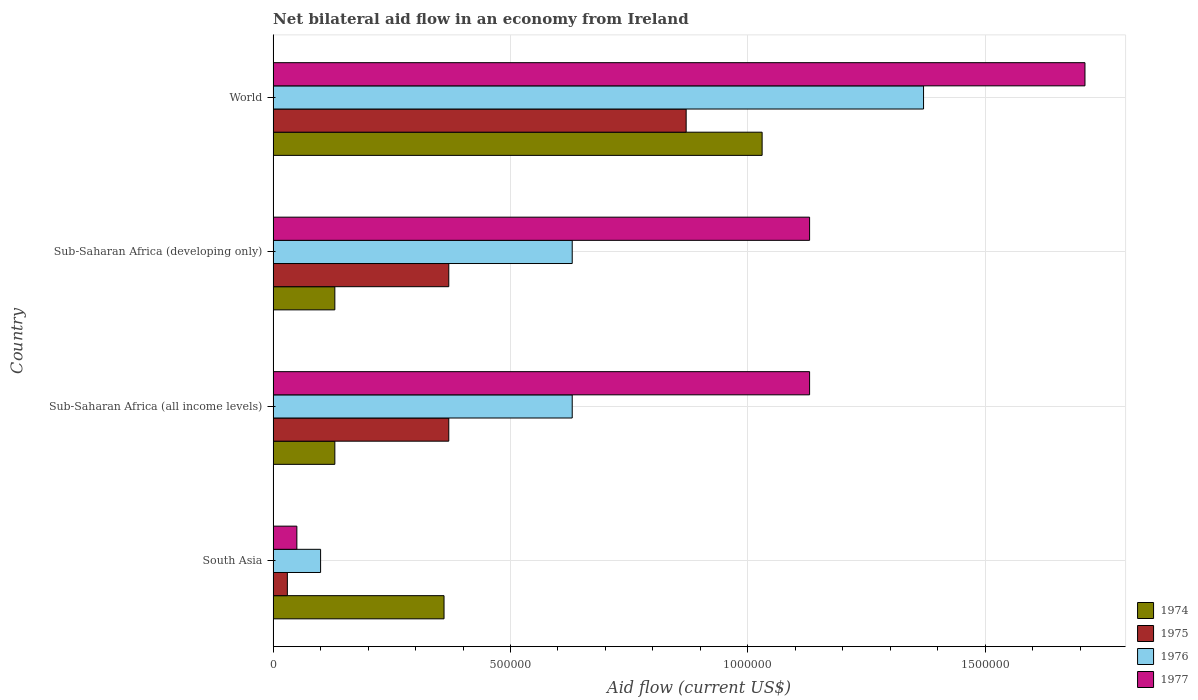How many bars are there on the 2nd tick from the top?
Offer a terse response. 4. What is the label of the 3rd group of bars from the top?
Provide a succinct answer. Sub-Saharan Africa (all income levels). Across all countries, what is the maximum net bilateral aid flow in 1975?
Your answer should be compact. 8.70e+05. Across all countries, what is the minimum net bilateral aid flow in 1977?
Your answer should be very brief. 5.00e+04. In which country was the net bilateral aid flow in 1977 maximum?
Give a very brief answer. World. What is the total net bilateral aid flow in 1974 in the graph?
Offer a terse response. 1.65e+06. What is the difference between the net bilateral aid flow in 1974 in South Asia and that in Sub-Saharan Africa (developing only)?
Ensure brevity in your answer.  2.30e+05. What is the difference between the net bilateral aid flow in 1974 in South Asia and the net bilateral aid flow in 1975 in Sub-Saharan Africa (all income levels)?
Ensure brevity in your answer.  -10000. What is the average net bilateral aid flow in 1977 per country?
Offer a very short reply. 1.00e+06. What is the difference between the net bilateral aid flow in 1974 and net bilateral aid flow in 1977 in World?
Offer a terse response. -6.80e+05. What is the ratio of the net bilateral aid flow in 1975 in Sub-Saharan Africa (developing only) to that in World?
Your answer should be compact. 0.43. Is the net bilateral aid flow in 1976 in South Asia less than that in Sub-Saharan Africa (developing only)?
Offer a very short reply. Yes. What is the difference between the highest and the second highest net bilateral aid flow in 1974?
Give a very brief answer. 6.70e+05. What is the difference between the highest and the lowest net bilateral aid flow in 1976?
Keep it short and to the point. 1.27e+06. Is the sum of the net bilateral aid flow in 1977 in Sub-Saharan Africa (developing only) and World greater than the maximum net bilateral aid flow in 1975 across all countries?
Ensure brevity in your answer.  Yes. Is it the case that in every country, the sum of the net bilateral aid flow in 1975 and net bilateral aid flow in 1974 is greater than the sum of net bilateral aid flow in 1977 and net bilateral aid flow in 1976?
Offer a very short reply. No. What does the 2nd bar from the top in South Asia represents?
Provide a succinct answer. 1976. Are all the bars in the graph horizontal?
Your answer should be very brief. Yes. Does the graph contain any zero values?
Your answer should be very brief. No. Does the graph contain grids?
Keep it short and to the point. Yes. Where does the legend appear in the graph?
Give a very brief answer. Bottom right. How many legend labels are there?
Ensure brevity in your answer.  4. How are the legend labels stacked?
Your answer should be compact. Vertical. What is the title of the graph?
Ensure brevity in your answer.  Net bilateral aid flow in an economy from Ireland. What is the label or title of the X-axis?
Offer a very short reply. Aid flow (current US$). What is the label or title of the Y-axis?
Offer a very short reply. Country. What is the Aid flow (current US$) in 1975 in Sub-Saharan Africa (all income levels)?
Make the answer very short. 3.70e+05. What is the Aid flow (current US$) in 1976 in Sub-Saharan Africa (all income levels)?
Make the answer very short. 6.30e+05. What is the Aid flow (current US$) in 1977 in Sub-Saharan Africa (all income levels)?
Provide a succinct answer. 1.13e+06. What is the Aid flow (current US$) of 1975 in Sub-Saharan Africa (developing only)?
Keep it short and to the point. 3.70e+05. What is the Aid flow (current US$) in 1976 in Sub-Saharan Africa (developing only)?
Your answer should be compact. 6.30e+05. What is the Aid flow (current US$) of 1977 in Sub-Saharan Africa (developing only)?
Ensure brevity in your answer.  1.13e+06. What is the Aid flow (current US$) of 1974 in World?
Make the answer very short. 1.03e+06. What is the Aid flow (current US$) of 1975 in World?
Offer a terse response. 8.70e+05. What is the Aid flow (current US$) of 1976 in World?
Offer a very short reply. 1.37e+06. What is the Aid flow (current US$) in 1977 in World?
Keep it short and to the point. 1.71e+06. Across all countries, what is the maximum Aid flow (current US$) in 1974?
Make the answer very short. 1.03e+06. Across all countries, what is the maximum Aid flow (current US$) of 1975?
Your response must be concise. 8.70e+05. Across all countries, what is the maximum Aid flow (current US$) of 1976?
Provide a succinct answer. 1.37e+06. Across all countries, what is the maximum Aid flow (current US$) of 1977?
Keep it short and to the point. 1.71e+06. Across all countries, what is the minimum Aid flow (current US$) of 1974?
Offer a very short reply. 1.30e+05. What is the total Aid flow (current US$) in 1974 in the graph?
Offer a very short reply. 1.65e+06. What is the total Aid flow (current US$) of 1975 in the graph?
Offer a very short reply. 1.64e+06. What is the total Aid flow (current US$) in 1976 in the graph?
Make the answer very short. 2.73e+06. What is the total Aid flow (current US$) in 1977 in the graph?
Give a very brief answer. 4.02e+06. What is the difference between the Aid flow (current US$) of 1976 in South Asia and that in Sub-Saharan Africa (all income levels)?
Your answer should be compact. -5.30e+05. What is the difference between the Aid flow (current US$) in 1977 in South Asia and that in Sub-Saharan Africa (all income levels)?
Make the answer very short. -1.08e+06. What is the difference between the Aid flow (current US$) of 1976 in South Asia and that in Sub-Saharan Africa (developing only)?
Your answer should be compact. -5.30e+05. What is the difference between the Aid flow (current US$) of 1977 in South Asia and that in Sub-Saharan Africa (developing only)?
Offer a terse response. -1.08e+06. What is the difference between the Aid flow (current US$) of 1974 in South Asia and that in World?
Your response must be concise. -6.70e+05. What is the difference between the Aid flow (current US$) of 1975 in South Asia and that in World?
Offer a terse response. -8.40e+05. What is the difference between the Aid flow (current US$) in 1976 in South Asia and that in World?
Offer a very short reply. -1.27e+06. What is the difference between the Aid flow (current US$) in 1977 in South Asia and that in World?
Provide a short and direct response. -1.66e+06. What is the difference between the Aid flow (current US$) in 1974 in Sub-Saharan Africa (all income levels) and that in Sub-Saharan Africa (developing only)?
Your answer should be compact. 0. What is the difference between the Aid flow (current US$) of 1975 in Sub-Saharan Africa (all income levels) and that in Sub-Saharan Africa (developing only)?
Your answer should be very brief. 0. What is the difference between the Aid flow (current US$) of 1976 in Sub-Saharan Africa (all income levels) and that in Sub-Saharan Africa (developing only)?
Provide a succinct answer. 0. What is the difference between the Aid flow (current US$) of 1974 in Sub-Saharan Africa (all income levels) and that in World?
Your answer should be very brief. -9.00e+05. What is the difference between the Aid flow (current US$) in 1975 in Sub-Saharan Africa (all income levels) and that in World?
Keep it short and to the point. -5.00e+05. What is the difference between the Aid flow (current US$) in 1976 in Sub-Saharan Africa (all income levels) and that in World?
Your response must be concise. -7.40e+05. What is the difference between the Aid flow (current US$) in 1977 in Sub-Saharan Africa (all income levels) and that in World?
Give a very brief answer. -5.80e+05. What is the difference between the Aid flow (current US$) in 1974 in Sub-Saharan Africa (developing only) and that in World?
Your answer should be compact. -9.00e+05. What is the difference between the Aid flow (current US$) in 1975 in Sub-Saharan Africa (developing only) and that in World?
Make the answer very short. -5.00e+05. What is the difference between the Aid flow (current US$) in 1976 in Sub-Saharan Africa (developing only) and that in World?
Make the answer very short. -7.40e+05. What is the difference between the Aid flow (current US$) in 1977 in Sub-Saharan Africa (developing only) and that in World?
Your response must be concise. -5.80e+05. What is the difference between the Aid flow (current US$) in 1974 in South Asia and the Aid flow (current US$) in 1975 in Sub-Saharan Africa (all income levels)?
Provide a short and direct response. -10000. What is the difference between the Aid flow (current US$) in 1974 in South Asia and the Aid flow (current US$) in 1977 in Sub-Saharan Africa (all income levels)?
Give a very brief answer. -7.70e+05. What is the difference between the Aid flow (current US$) of 1975 in South Asia and the Aid flow (current US$) of 1976 in Sub-Saharan Africa (all income levels)?
Your response must be concise. -6.00e+05. What is the difference between the Aid flow (current US$) in 1975 in South Asia and the Aid flow (current US$) in 1977 in Sub-Saharan Africa (all income levels)?
Give a very brief answer. -1.10e+06. What is the difference between the Aid flow (current US$) of 1976 in South Asia and the Aid flow (current US$) of 1977 in Sub-Saharan Africa (all income levels)?
Provide a succinct answer. -1.03e+06. What is the difference between the Aid flow (current US$) in 1974 in South Asia and the Aid flow (current US$) in 1976 in Sub-Saharan Africa (developing only)?
Provide a short and direct response. -2.70e+05. What is the difference between the Aid flow (current US$) of 1974 in South Asia and the Aid flow (current US$) of 1977 in Sub-Saharan Africa (developing only)?
Your answer should be very brief. -7.70e+05. What is the difference between the Aid flow (current US$) in 1975 in South Asia and the Aid flow (current US$) in 1976 in Sub-Saharan Africa (developing only)?
Give a very brief answer. -6.00e+05. What is the difference between the Aid flow (current US$) of 1975 in South Asia and the Aid flow (current US$) of 1977 in Sub-Saharan Africa (developing only)?
Offer a terse response. -1.10e+06. What is the difference between the Aid flow (current US$) in 1976 in South Asia and the Aid flow (current US$) in 1977 in Sub-Saharan Africa (developing only)?
Ensure brevity in your answer.  -1.03e+06. What is the difference between the Aid flow (current US$) in 1974 in South Asia and the Aid flow (current US$) in 1975 in World?
Your answer should be compact. -5.10e+05. What is the difference between the Aid flow (current US$) of 1974 in South Asia and the Aid flow (current US$) of 1976 in World?
Your response must be concise. -1.01e+06. What is the difference between the Aid flow (current US$) in 1974 in South Asia and the Aid flow (current US$) in 1977 in World?
Make the answer very short. -1.35e+06. What is the difference between the Aid flow (current US$) of 1975 in South Asia and the Aid flow (current US$) of 1976 in World?
Offer a terse response. -1.34e+06. What is the difference between the Aid flow (current US$) of 1975 in South Asia and the Aid flow (current US$) of 1977 in World?
Make the answer very short. -1.68e+06. What is the difference between the Aid flow (current US$) of 1976 in South Asia and the Aid flow (current US$) of 1977 in World?
Offer a very short reply. -1.61e+06. What is the difference between the Aid flow (current US$) in 1974 in Sub-Saharan Africa (all income levels) and the Aid flow (current US$) in 1975 in Sub-Saharan Africa (developing only)?
Provide a succinct answer. -2.40e+05. What is the difference between the Aid flow (current US$) of 1974 in Sub-Saharan Africa (all income levels) and the Aid flow (current US$) of 1976 in Sub-Saharan Africa (developing only)?
Give a very brief answer. -5.00e+05. What is the difference between the Aid flow (current US$) in 1975 in Sub-Saharan Africa (all income levels) and the Aid flow (current US$) in 1976 in Sub-Saharan Africa (developing only)?
Make the answer very short. -2.60e+05. What is the difference between the Aid flow (current US$) in 1975 in Sub-Saharan Africa (all income levels) and the Aid flow (current US$) in 1977 in Sub-Saharan Africa (developing only)?
Give a very brief answer. -7.60e+05. What is the difference between the Aid flow (current US$) in 1976 in Sub-Saharan Africa (all income levels) and the Aid flow (current US$) in 1977 in Sub-Saharan Africa (developing only)?
Offer a very short reply. -5.00e+05. What is the difference between the Aid flow (current US$) of 1974 in Sub-Saharan Africa (all income levels) and the Aid flow (current US$) of 1975 in World?
Make the answer very short. -7.40e+05. What is the difference between the Aid flow (current US$) in 1974 in Sub-Saharan Africa (all income levels) and the Aid flow (current US$) in 1976 in World?
Your response must be concise. -1.24e+06. What is the difference between the Aid flow (current US$) of 1974 in Sub-Saharan Africa (all income levels) and the Aid flow (current US$) of 1977 in World?
Give a very brief answer. -1.58e+06. What is the difference between the Aid flow (current US$) in 1975 in Sub-Saharan Africa (all income levels) and the Aid flow (current US$) in 1977 in World?
Offer a very short reply. -1.34e+06. What is the difference between the Aid flow (current US$) in 1976 in Sub-Saharan Africa (all income levels) and the Aid flow (current US$) in 1977 in World?
Provide a short and direct response. -1.08e+06. What is the difference between the Aid flow (current US$) in 1974 in Sub-Saharan Africa (developing only) and the Aid flow (current US$) in 1975 in World?
Provide a short and direct response. -7.40e+05. What is the difference between the Aid flow (current US$) in 1974 in Sub-Saharan Africa (developing only) and the Aid flow (current US$) in 1976 in World?
Your answer should be compact. -1.24e+06. What is the difference between the Aid flow (current US$) of 1974 in Sub-Saharan Africa (developing only) and the Aid flow (current US$) of 1977 in World?
Your answer should be compact. -1.58e+06. What is the difference between the Aid flow (current US$) of 1975 in Sub-Saharan Africa (developing only) and the Aid flow (current US$) of 1977 in World?
Make the answer very short. -1.34e+06. What is the difference between the Aid flow (current US$) of 1976 in Sub-Saharan Africa (developing only) and the Aid flow (current US$) of 1977 in World?
Your answer should be compact. -1.08e+06. What is the average Aid flow (current US$) of 1974 per country?
Give a very brief answer. 4.12e+05. What is the average Aid flow (current US$) in 1975 per country?
Ensure brevity in your answer.  4.10e+05. What is the average Aid flow (current US$) in 1976 per country?
Offer a terse response. 6.82e+05. What is the average Aid flow (current US$) in 1977 per country?
Ensure brevity in your answer.  1.00e+06. What is the difference between the Aid flow (current US$) in 1974 and Aid flow (current US$) in 1975 in South Asia?
Provide a short and direct response. 3.30e+05. What is the difference between the Aid flow (current US$) in 1974 and Aid flow (current US$) in 1976 in South Asia?
Offer a very short reply. 2.60e+05. What is the difference between the Aid flow (current US$) of 1974 and Aid flow (current US$) of 1977 in South Asia?
Offer a terse response. 3.10e+05. What is the difference between the Aid flow (current US$) in 1976 and Aid flow (current US$) in 1977 in South Asia?
Give a very brief answer. 5.00e+04. What is the difference between the Aid flow (current US$) of 1974 and Aid flow (current US$) of 1975 in Sub-Saharan Africa (all income levels)?
Your answer should be compact. -2.40e+05. What is the difference between the Aid flow (current US$) in 1974 and Aid flow (current US$) in 1976 in Sub-Saharan Africa (all income levels)?
Make the answer very short. -5.00e+05. What is the difference between the Aid flow (current US$) in 1974 and Aid flow (current US$) in 1977 in Sub-Saharan Africa (all income levels)?
Offer a very short reply. -1.00e+06. What is the difference between the Aid flow (current US$) in 1975 and Aid flow (current US$) in 1977 in Sub-Saharan Africa (all income levels)?
Your answer should be very brief. -7.60e+05. What is the difference between the Aid flow (current US$) of 1976 and Aid flow (current US$) of 1977 in Sub-Saharan Africa (all income levels)?
Ensure brevity in your answer.  -5.00e+05. What is the difference between the Aid flow (current US$) in 1974 and Aid flow (current US$) in 1976 in Sub-Saharan Africa (developing only)?
Ensure brevity in your answer.  -5.00e+05. What is the difference between the Aid flow (current US$) in 1974 and Aid flow (current US$) in 1977 in Sub-Saharan Africa (developing only)?
Offer a terse response. -1.00e+06. What is the difference between the Aid flow (current US$) of 1975 and Aid flow (current US$) of 1976 in Sub-Saharan Africa (developing only)?
Your answer should be compact. -2.60e+05. What is the difference between the Aid flow (current US$) of 1975 and Aid flow (current US$) of 1977 in Sub-Saharan Africa (developing only)?
Provide a short and direct response. -7.60e+05. What is the difference between the Aid flow (current US$) in 1976 and Aid flow (current US$) in 1977 in Sub-Saharan Africa (developing only)?
Make the answer very short. -5.00e+05. What is the difference between the Aid flow (current US$) in 1974 and Aid flow (current US$) in 1976 in World?
Keep it short and to the point. -3.40e+05. What is the difference between the Aid flow (current US$) of 1974 and Aid flow (current US$) of 1977 in World?
Provide a short and direct response. -6.80e+05. What is the difference between the Aid flow (current US$) of 1975 and Aid flow (current US$) of 1976 in World?
Your response must be concise. -5.00e+05. What is the difference between the Aid flow (current US$) of 1975 and Aid flow (current US$) of 1977 in World?
Make the answer very short. -8.40e+05. What is the difference between the Aid flow (current US$) in 1976 and Aid flow (current US$) in 1977 in World?
Offer a terse response. -3.40e+05. What is the ratio of the Aid flow (current US$) in 1974 in South Asia to that in Sub-Saharan Africa (all income levels)?
Make the answer very short. 2.77. What is the ratio of the Aid flow (current US$) of 1975 in South Asia to that in Sub-Saharan Africa (all income levels)?
Your answer should be compact. 0.08. What is the ratio of the Aid flow (current US$) in 1976 in South Asia to that in Sub-Saharan Africa (all income levels)?
Ensure brevity in your answer.  0.16. What is the ratio of the Aid flow (current US$) of 1977 in South Asia to that in Sub-Saharan Africa (all income levels)?
Provide a succinct answer. 0.04. What is the ratio of the Aid flow (current US$) in 1974 in South Asia to that in Sub-Saharan Africa (developing only)?
Make the answer very short. 2.77. What is the ratio of the Aid flow (current US$) of 1975 in South Asia to that in Sub-Saharan Africa (developing only)?
Your response must be concise. 0.08. What is the ratio of the Aid flow (current US$) in 1976 in South Asia to that in Sub-Saharan Africa (developing only)?
Offer a terse response. 0.16. What is the ratio of the Aid flow (current US$) in 1977 in South Asia to that in Sub-Saharan Africa (developing only)?
Provide a short and direct response. 0.04. What is the ratio of the Aid flow (current US$) of 1974 in South Asia to that in World?
Give a very brief answer. 0.35. What is the ratio of the Aid flow (current US$) in 1975 in South Asia to that in World?
Provide a succinct answer. 0.03. What is the ratio of the Aid flow (current US$) in 1976 in South Asia to that in World?
Give a very brief answer. 0.07. What is the ratio of the Aid flow (current US$) of 1977 in South Asia to that in World?
Your answer should be compact. 0.03. What is the ratio of the Aid flow (current US$) in 1975 in Sub-Saharan Africa (all income levels) to that in Sub-Saharan Africa (developing only)?
Offer a terse response. 1. What is the ratio of the Aid flow (current US$) of 1976 in Sub-Saharan Africa (all income levels) to that in Sub-Saharan Africa (developing only)?
Ensure brevity in your answer.  1. What is the ratio of the Aid flow (current US$) of 1977 in Sub-Saharan Africa (all income levels) to that in Sub-Saharan Africa (developing only)?
Offer a very short reply. 1. What is the ratio of the Aid flow (current US$) of 1974 in Sub-Saharan Africa (all income levels) to that in World?
Keep it short and to the point. 0.13. What is the ratio of the Aid flow (current US$) in 1975 in Sub-Saharan Africa (all income levels) to that in World?
Offer a very short reply. 0.43. What is the ratio of the Aid flow (current US$) of 1976 in Sub-Saharan Africa (all income levels) to that in World?
Give a very brief answer. 0.46. What is the ratio of the Aid flow (current US$) of 1977 in Sub-Saharan Africa (all income levels) to that in World?
Provide a succinct answer. 0.66. What is the ratio of the Aid flow (current US$) in 1974 in Sub-Saharan Africa (developing only) to that in World?
Your answer should be compact. 0.13. What is the ratio of the Aid flow (current US$) of 1975 in Sub-Saharan Africa (developing only) to that in World?
Provide a succinct answer. 0.43. What is the ratio of the Aid flow (current US$) in 1976 in Sub-Saharan Africa (developing only) to that in World?
Offer a very short reply. 0.46. What is the ratio of the Aid flow (current US$) of 1977 in Sub-Saharan Africa (developing only) to that in World?
Your answer should be compact. 0.66. What is the difference between the highest and the second highest Aid flow (current US$) of 1974?
Offer a very short reply. 6.70e+05. What is the difference between the highest and the second highest Aid flow (current US$) of 1976?
Offer a very short reply. 7.40e+05. What is the difference between the highest and the second highest Aid flow (current US$) of 1977?
Offer a terse response. 5.80e+05. What is the difference between the highest and the lowest Aid flow (current US$) of 1975?
Provide a succinct answer. 8.40e+05. What is the difference between the highest and the lowest Aid flow (current US$) in 1976?
Provide a succinct answer. 1.27e+06. What is the difference between the highest and the lowest Aid flow (current US$) in 1977?
Make the answer very short. 1.66e+06. 